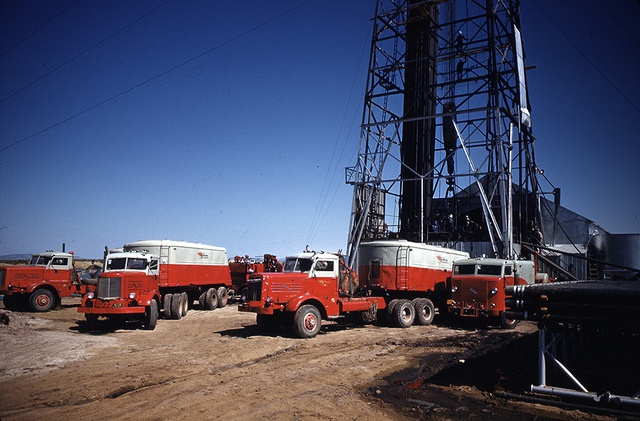Describe the objects in this image and their specific colors. I can see truck in black, red, white, and brown tones, truck in black, brown, lightgray, and gray tones, truck in black, maroon, darkgray, and brown tones, and truck in black, brown, maroon, and gray tones in this image. 